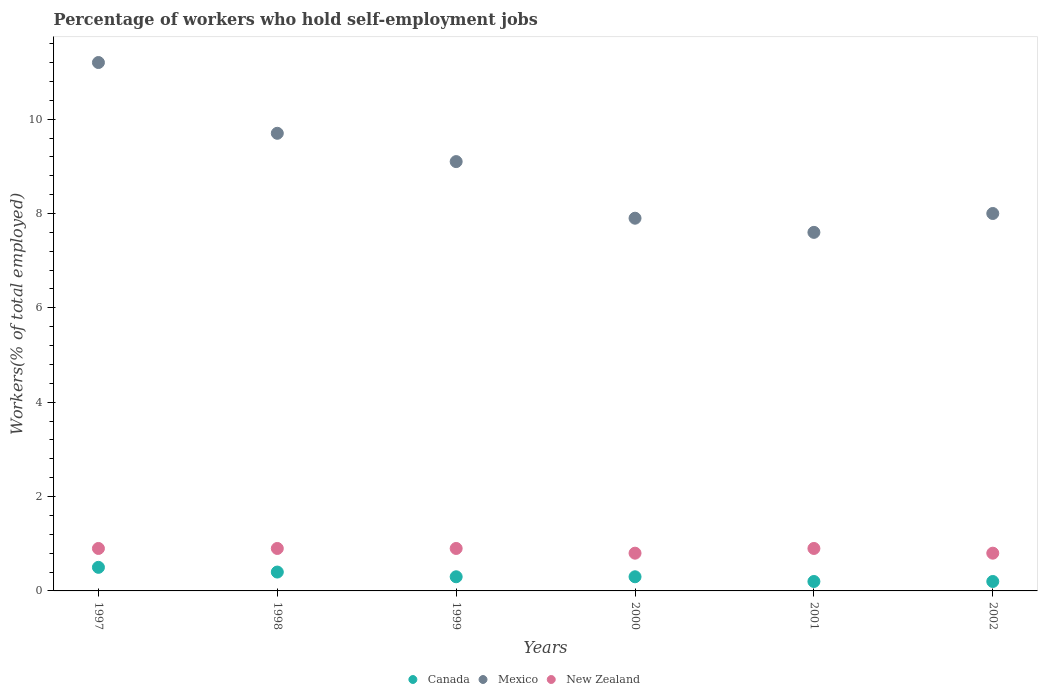How many different coloured dotlines are there?
Offer a terse response. 3. Is the number of dotlines equal to the number of legend labels?
Your answer should be very brief. Yes. What is the percentage of self-employed workers in New Zealand in 1999?
Your answer should be compact. 0.9. Across all years, what is the maximum percentage of self-employed workers in Mexico?
Provide a succinct answer. 11.2. Across all years, what is the minimum percentage of self-employed workers in New Zealand?
Your answer should be compact. 0.8. What is the total percentage of self-employed workers in New Zealand in the graph?
Provide a short and direct response. 5.2. What is the difference between the percentage of self-employed workers in Canada in 1997 and that in 1999?
Give a very brief answer. 0.2. What is the difference between the percentage of self-employed workers in Mexico in 1998 and the percentage of self-employed workers in Canada in 2001?
Your response must be concise. 9.5. What is the average percentage of self-employed workers in Mexico per year?
Offer a very short reply. 8.92. In the year 1997, what is the difference between the percentage of self-employed workers in Canada and percentage of self-employed workers in New Zealand?
Your response must be concise. -0.4. In how many years, is the percentage of self-employed workers in Canada greater than 3.2 %?
Give a very brief answer. 0. What is the difference between the highest and the second highest percentage of self-employed workers in Mexico?
Keep it short and to the point. 1.5. What is the difference between the highest and the lowest percentage of self-employed workers in Mexico?
Your response must be concise. 3.6. In how many years, is the percentage of self-employed workers in New Zealand greater than the average percentage of self-employed workers in New Zealand taken over all years?
Make the answer very short. 4. Is the sum of the percentage of self-employed workers in Canada in 1999 and 2000 greater than the maximum percentage of self-employed workers in Mexico across all years?
Ensure brevity in your answer.  No. Does the percentage of self-employed workers in Mexico monotonically increase over the years?
Offer a very short reply. No. How many years are there in the graph?
Your response must be concise. 6. What is the difference between two consecutive major ticks on the Y-axis?
Offer a terse response. 2. Does the graph contain any zero values?
Provide a succinct answer. No. Where does the legend appear in the graph?
Your response must be concise. Bottom center. How are the legend labels stacked?
Offer a very short reply. Horizontal. What is the title of the graph?
Keep it short and to the point. Percentage of workers who hold self-employment jobs. Does "Malta" appear as one of the legend labels in the graph?
Your answer should be very brief. No. What is the label or title of the X-axis?
Offer a very short reply. Years. What is the label or title of the Y-axis?
Make the answer very short. Workers(% of total employed). What is the Workers(% of total employed) of Mexico in 1997?
Your answer should be compact. 11.2. What is the Workers(% of total employed) in New Zealand in 1997?
Offer a very short reply. 0.9. What is the Workers(% of total employed) of Canada in 1998?
Offer a very short reply. 0.4. What is the Workers(% of total employed) of Mexico in 1998?
Offer a very short reply. 9.7. What is the Workers(% of total employed) in New Zealand in 1998?
Offer a terse response. 0.9. What is the Workers(% of total employed) of Canada in 1999?
Provide a succinct answer. 0.3. What is the Workers(% of total employed) in Mexico in 1999?
Offer a terse response. 9.1. What is the Workers(% of total employed) of New Zealand in 1999?
Offer a very short reply. 0.9. What is the Workers(% of total employed) of Canada in 2000?
Offer a very short reply. 0.3. What is the Workers(% of total employed) of Mexico in 2000?
Make the answer very short. 7.9. What is the Workers(% of total employed) of New Zealand in 2000?
Your answer should be very brief. 0.8. What is the Workers(% of total employed) of Canada in 2001?
Offer a terse response. 0.2. What is the Workers(% of total employed) of Mexico in 2001?
Offer a very short reply. 7.6. What is the Workers(% of total employed) in New Zealand in 2001?
Offer a very short reply. 0.9. What is the Workers(% of total employed) of Canada in 2002?
Make the answer very short. 0.2. What is the Workers(% of total employed) in Mexico in 2002?
Your answer should be compact. 8. What is the Workers(% of total employed) in New Zealand in 2002?
Make the answer very short. 0.8. Across all years, what is the maximum Workers(% of total employed) in Canada?
Ensure brevity in your answer.  0.5. Across all years, what is the maximum Workers(% of total employed) in Mexico?
Give a very brief answer. 11.2. Across all years, what is the maximum Workers(% of total employed) of New Zealand?
Your answer should be very brief. 0.9. Across all years, what is the minimum Workers(% of total employed) of Canada?
Offer a very short reply. 0.2. Across all years, what is the minimum Workers(% of total employed) of Mexico?
Make the answer very short. 7.6. Across all years, what is the minimum Workers(% of total employed) in New Zealand?
Offer a very short reply. 0.8. What is the total Workers(% of total employed) of Mexico in the graph?
Give a very brief answer. 53.5. What is the difference between the Workers(% of total employed) of Canada in 1997 and that in 1998?
Your answer should be very brief. 0.1. What is the difference between the Workers(% of total employed) in New Zealand in 1997 and that in 1998?
Provide a succinct answer. 0. What is the difference between the Workers(% of total employed) of Canada in 1997 and that in 1999?
Give a very brief answer. 0.2. What is the difference between the Workers(% of total employed) of Mexico in 1997 and that in 1999?
Your response must be concise. 2.1. What is the difference between the Workers(% of total employed) of Canada in 1997 and that in 2000?
Keep it short and to the point. 0.2. What is the difference between the Workers(% of total employed) of New Zealand in 1997 and that in 2000?
Your response must be concise. 0.1. What is the difference between the Workers(% of total employed) in Canada in 1997 and that in 2001?
Your response must be concise. 0.3. What is the difference between the Workers(% of total employed) of Mexico in 1997 and that in 2001?
Make the answer very short. 3.6. What is the difference between the Workers(% of total employed) in New Zealand in 1997 and that in 2001?
Ensure brevity in your answer.  0. What is the difference between the Workers(% of total employed) of Mexico in 1997 and that in 2002?
Provide a succinct answer. 3.2. What is the difference between the Workers(% of total employed) in Mexico in 1998 and that in 1999?
Provide a succinct answer. 0.6. What is the difference between the Workers(% of total employed) in New Zealand in 1998 and that in 1999?
Make the answer very short. 0. What is the difference between the Workers(% of total employed) in Canada in 1998 and that in 2000?
Give a very brief answer. 0.1. What is the difference between the Workers(% of total employed) in Mexico in 1998 and that in 2000?
Your answer should be very brief. 1.8. What is the difference between the Workers(% of total employed) in Mexico in 1998 and that in 2001?
Provide a short and direct response. 2.1. What is the difference between the Workers(% of total employed) of Canada in 1998 and that in 2002?
Keep it short and to the point. 0.2. What is the difference between the Workers(% of total employed) in Canada in 1999 and that in 2000?
Ensure brevity in your answer.  0. What is the difference between the Workers(% of total employed) of Mexico in 1999 and that in 2000?
Provide a short and direct response. 1.2. What is the difference between the Workers(% of total employed) of Canada in 1999 and that in 2001?
Your response must be concise. 0.1. What is the difference between the Workers(% of total employed) of Mexico in 1999 and that in 2001?
Provide a short and direct response. 1.5. What is the difference between the Workers(% of total employed) in New Zealand in 1999 and that in 2001?
Offer a terse response. 0. What is the difference between the Workers(% of total employed) of Canada in 1999 and that in 2002?
Your answer should be very brief. 0.1. What is the difference between the Workers(% of total employed) of Mexico in 1999 and that in 2002?
Offer a terse response. 1.1. What is the difference between the Workers(% of total employed) of New Zealand in 1999 and that in 2002?
Your response must be concise. 0.1. What is the difference between the Workers(% of total employed) in Mexico in 2000 and that in 2001?
Your response must be concise. 0.3. What is the difference between the Workers(% of total employed) of Canada in 2000 and that in 2002?
Ensure brevity in your answer.  0.1. What is the difference between the Workers(% of total employed) in Mexico in 2000 and that in 2002?
Keep it short and to the point. -0.1. What is the difference between the Workers(% of total employed) in Mexico in 2001 and that in 2002?
Offer a terse response. -0.4. What is the difference between the Workers(% of total employed) in New Zealand in 2001 and that in 2002?
Keep it short and to the point. 0.1. What is the difference between the Workers(% of total employed) of Canada in 1997 and the Workers(% of total employed) of Mexico in 2000?
Your answer should be compact. -7.4. What is the difference between the Workers(% of total employed) of Canada in 1997 and the Workers(% of total employed) of New Zealand in 2000?
Offer a terse response. -0.3. What is the difference between the Workers(% of total employed) of Canada in 1997 and the Workers(% of total employed) of Mexico in 2001?
Make the answer very short. -7.1. What is the difference between the Workers(% of total employed) in Mexico in 1997 and the Workers(% of total employed) in New Zealand in 2001?
Your answer should be very brief. 10.3. What is the difference between the Workers(% of total employed) in Canada in 1997 and the Workers(% of total employed) in Mexico in 2002?
Ensure brevity in your answer.  -7.5. What is the difference between the Workers(% of total employed) in Canada in 1997 and the Workers(% of total employed) in New Zealand in 2002?
Make the answer very short. -0.3. What is the difference between the Workers(% of total employed) in Mexico in 1997 and the Workers(% of total employed) in New Zealand in 2002?
Your answer should be very brief. 10.4. What is the difference between the Workers(% of total employed) of Canada in 1998 and the Workers(% of total employed) of Mexico in 1999?
Provide a succinct answer. -8.7. What is the difference between the Workers(% of total employed) of Canada in 1998 and the Workers(% of total employed) of New Zealand in 1999?
Keep it short and to the point. -0.5. What is the difference between the Workers(% of total employed) in Mexico in 1998 and the Workers(% of total employed) in New Zealand in 1999?
Offer a terse response. 8.8. What is the difference between the Workers(% of total employed) of Canada in 1998 and the Workers(% of total employed) of Mexico in 2000?
Keep it short and to the point. -7.5. What is the difference between the Workers(% of total employed) of Canada in 1998 and the Workers(% of total employed) of New Zealand in 2000?
Make the answer very short. -0.4. What is the difference between the Workers(% of total employed) of Canada in 1998 and the Workers(% of total employed) of New Zealand in 2001?
Ensure brevity in your answer.  -0.5. What is the difference between the Workers(% of total employed) of Mexico in 1998 and the Workers(% of total employed) of New Zealand in 2001?
Keep it short and to the point. 8.8. What is the difference between the Workers(% of total employed) of Canada in 1998 and the Workers(% of total employed) of Mexico in 2002?
Your answer should be very brief. -7.6. What is the difference between the Workers(% of total employed) in Canada in 1998 and the Workers(% of total employed) in New Zealand in 2002?
Provide a short and direct response. -0.4. What is the difference between the Workers(% of total employed) of Canada in 1999 and the Workers(% of total employed) of New Zealand in 2000?
Provide a succinct answer. -0.5. What is the difference between the Workers(% of total employed) of Mexico in 1999 and the Workers(% of total employed) of New Zealand in 2000?
Ensure brevity in your answer.  8.3. What is the difference between the Workers(% of total employed) in Canada in 1999 and the Workers(% of total employed) in Mexico in 2001?
Your answer should be compact. -7.3. What is the difference between the Workers(% of total employed) of Canada in 1999 and the Workers(% of total employed) of Mexico in 2002?
Offer a very short reply. -7.7. What is the difference between the Workers(% of total employed) in Canada in 2000 and the Workers(% of total employed) in New Zealand in 2001?
Offer a terse response. -0.6. What is the difference between the Workers(% of total employed) of Canada in 2000 and the Workers(% of total employed) of New Zealand in 2002?
Your answer should be compact. -0.5. What is the difference between the Workers(% of total employed) of Canada in 2001 and the Workers(% of total employed) of Mexico in 2002?
Offer a terse response. -7.8. What is the difference between the Workers(% of total employed) in Canada in 2001 and the Workers(% of total employed) in New Zealand in 2002?
Provide a succinct answer. -0.6. What is the difference between the Workers(% of total employed) of Mexico in 2001 and the Workers(% of total employed) of New Zealand in 2002?
Provide a short and direct response. 6.8. What is the average Workers(% of total employed) in Canada per year?
Ensure brevity in your answer.  0.32. What is the average Workers(% of total employed) in Mexico per year?
Your answer should be very brief. 8.92. What is the average Workers(% of total employed) of New Zealand per year?
Offer a terse response. 0.87. In the year 1997, what is the difference between the Workers(% of total employed) in Canada and Workers(% of total employed) in Mexico?
Offer a very short reply. -10.7. In the year 1997, what is the difference between the Workers(% of total employed) of Mexico and Workers(% of total employed) of New Zealand?
Offer a terse response. 10.3. In the year 1998, what is the difference between the Workers(% of total employed) of Canada and Workers(% of total employed) of Mexico?
Ensure brevity in your answer.  -9.3. In the year 1998, what is the difference between the Workers(% of total employed) in Canada and Workers(% of total employed) in New Zealand?
Keep it short and to the point. -0.5. In the year 1998, what is the difference between the Workers(% of total employed) in Mexico and Workers(% of total employed) in New Zealand?
Provide a short and direct response. 8.8. In the year 1999, what is the difference between the Workers(% of total employed) in Canada and Workers(% of total employed) in Mexico?
Give a very brief answer. -8.8. In the year 1999, what is the difference between the Workers(% of total employed) in Mexico and Workers(% of total employed) in New Zealand?
Provide a short and direct response. 8.2. In the year 2000, what is the difference between the Workers(% of total employed) of Canada and Workers(% of total employed) of New Zealand?
Ensure brevity in your answer.  -0.5. In the year 2000, what is the difference between the Workers(% of total employed) of Mexico and Workers(% of total employed) of New Zealand?
Give a very brief answer. 7.1. In the year 2001, what is the difference between the Workers(% of total employed) in Canada and Workers(% of total employed) in New Zealand?
Your answer should be compact. -0.7. In the year 2002, what is the difference between the Workers(% of total employed) of Canada and Workers(% of total employed) of New Zealand?
Make the answer very short. -0.6. In the year 2002, what is the difference between the Workers(% of total employed) in Mexico and Workers(% of total employed) in New Zealand?
Make the answer very short. 7.2. What is the ratio of the Workers(% of total employed) in Canada in 1997 to that in 1998?
Offer a very short reply. 1.25. What is the ratio of the Workers(% of total employed) in Mexico in 1997 to that in 1998?
Give a very brief answer. 1.15. What is the ratio of the Workers(% of total employed) of New Zealand in 1997 to that in 1998?
Your response must be concise. 1. What is the ratio of the Workers(% of total employed) of Canada in 1997 to that in 1999?
Provide a short and direct response. 1.67. What is the ratio of the Workers(% of total employed) in Mexico in 1997 to that in 1999?
Your response must be concise. 1.23. What is the ratio of the Workers(% of total employed) in Mexico in 1997 to that in 2000?
Your answer should be very brief. 1.42. What is the ratio of the Workers(% of total employed) in Mexico in 1997 to that in 2001?
Your response must be concise. 1.47. What is the ratio of the Workers(% of total employed) in New Zealand in 1997 to that in 2001?
Keep it short and to the point. 1. What is the ratio of the Workers(% of total employed) in Canada in 1998 to that in 1999?
Your response must be concise. 1.33. What is the ratio of the Workers(% of total employed) in Mexico in 1998 to that in 1999?
Your response must be concise. 1.07. What is the ratio of the Workers(% of total employed) of Mexico in 1998 to that in 2000?
Ensure brevity in your answer.  1.23. What is the ratio of the Workers(% of total employed) of Canada in 1998 to that in 2001?
Provide a short and direct response. 2. What is the ratio of the Workers(% of total employed) of Mexico in 1998 to that in 2001?
Offer a terse response. 1.28. What is the ratio of the Workers(% of total employed) in Canada in 1998 to that in 2002?
Your answer should be compact. 2. What is the ratio of the Workers(% of total employed) of Mexico in 1998 to that in 2002?
Offer a very short reply. 1.21. What is the ratio of the Workers(% of total employed) in New Zealand in 1998 to that in 2002?
Offer a terse response. 1.12. What is the ratio of the Workers(% of total employed) in Canada in 1999 to that in 2000?
Give a very brief answer. 1. What is the ratio of the Workers(% of total employed) in Mexico in 1999 to that in 2000?
Give a very brief answer. 1.15. What is the ratio of the Workers(% of total employed) in Canada in 1999 to that in 2001?
Your answer should be compact. 1.5. What is the ratio of the Workers(% of total employed) of Mexico in 1999 to that in 2001?
Your answer should be compact. 1.2. What is the ratio of the Workers(% of total employed) in Canada in 1999 to that in 2002?
Keep it short and to the point. 1.5. What is the ratio of the Workers(% of total employed) of Mexico in 1999 to that in 2002?
Your answer should be compact. 1.14. What is the ratio of the Workers(% of total employed) in Mexico in 2000 to that in 2001?
Ensure brevity in your answer.  1.04. What is the ratio of the Workers(% of total employed) in New Zealand in 2000 to that in 2001?
Keep it short and to the point. 0.89. What is the ratio of the Workers(% of total employed) of Canada in 2000 to that in 2002?
Your answer should be compact. 1.5. What is the ratio of the Workers(% of total employed) of Mexico in 2000 to that in 2002?
Provide a short and direct response. 0.99. What is the ratio of the Workers(% of total employed) in New Zealand in 2000 to that in 2002?
Provide a succinct answer. 1. What is the ratio of the Workers(% of total employed) in Mexico in 2001 to that in 2002?
Give a very brief answer. 0.95. What is the difference between the highest and the second highest Workers(% of total employed) of New Zealand?
Make the answer very short. 0. What is the difference between the highest and the lowest Workers(% of total employed) of Canada?
Offer a terse response. 0.3. What is the difference between the highest and the lowest Workers(% of total employed) of Mexico?
Your answer should be compact. 3.6. 